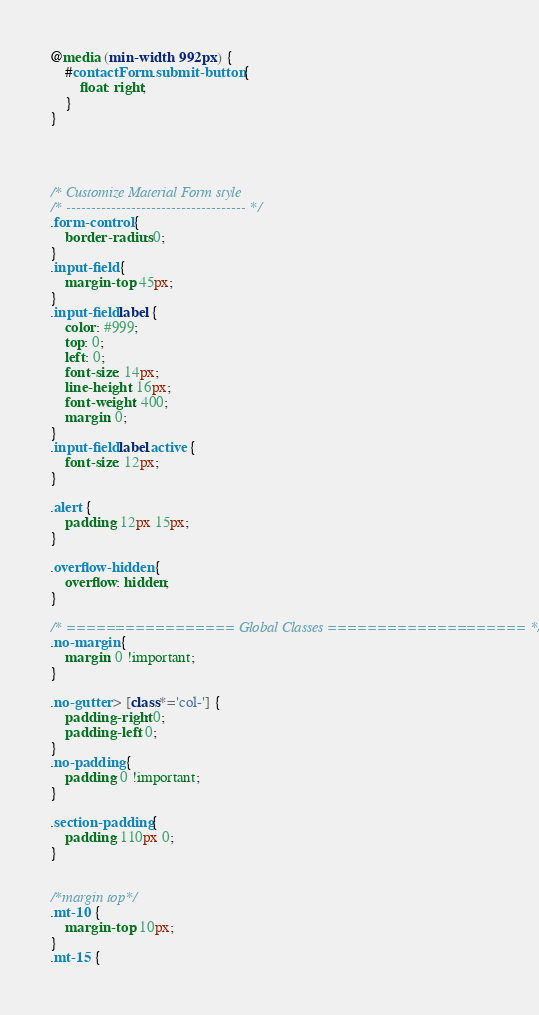Convert code to text. <code><loc_0><loc_0><loc_500><loc_500><_CSS_>
@media (min-width: 992px) {
    #contactForm .submit-button {
        float: right;
    }
}




/* Customize Material Form style 
/* ------------------------------------ */
.form-control {
    border-radius: 0;
}
.input-field {
    margin-top: 45px;
}
.input-field label {
    color: #999;
    top: 0;
    left: 0;
    font-size: 14px;
    line-height: 16px;
    font-weight: 400;
    margin: 0;
}
.input-field label.active {
    font-size: 12px;
}

.alert {
    padding: 12px 15px;
}

.overflow-hidden {
	overflow: hidden;
}

/* ================= Global Classes ==================== */
.no-margin {
    margin: 0 !important;
}

.no-gutter > [class*='col-'] {
    padding-right: 0;
    padding-left: 0;
}
.no-padding {
    padding: 0 !important;
}

.section-padding {
    padding: 110px 0;
}


/*margin top*/
.mt-10 {
    margin-top: 10px;
}
.mt-15 {</code> 